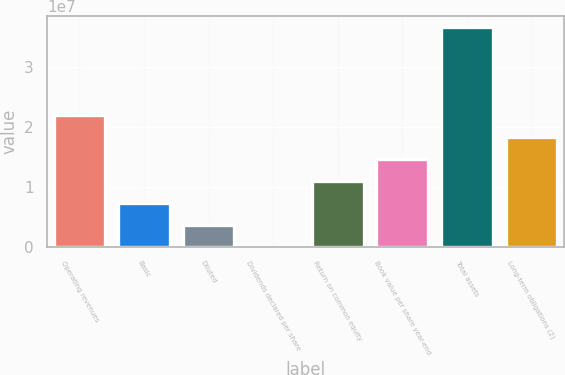Convert chart to OTSL. <chart><loc_0><loc_0><loc_500><loc_500><bar_chart><fcel>Operating revenues<fcel>Basic<fcel>Diluted<fcel>Dividends declared per share<fcel>Return on common equity<fcel>Book value per share year-end<fcel>Total assets<fcel>Long-term obligations (2)<nl><fcel>2.19701e+07<fcel>7.32337e+06<fcel>3.66168e+06<fcel>3<fcel>1.0985e+07<fcel>1.46467e+07<fcel>3.66168e+07<fcel>1.83084e+07<nl></chart> 